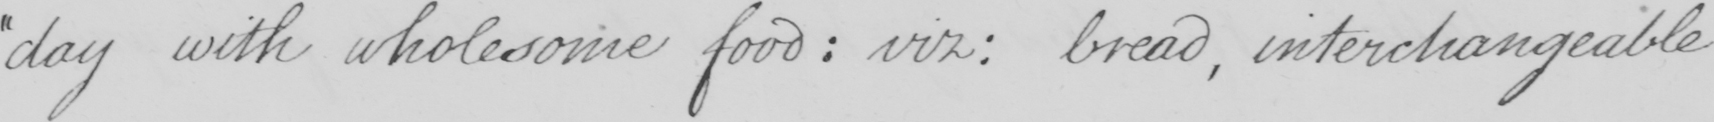What is written in this line of handwriting? day with wholesome food :  viz :  bread , interchangeable 